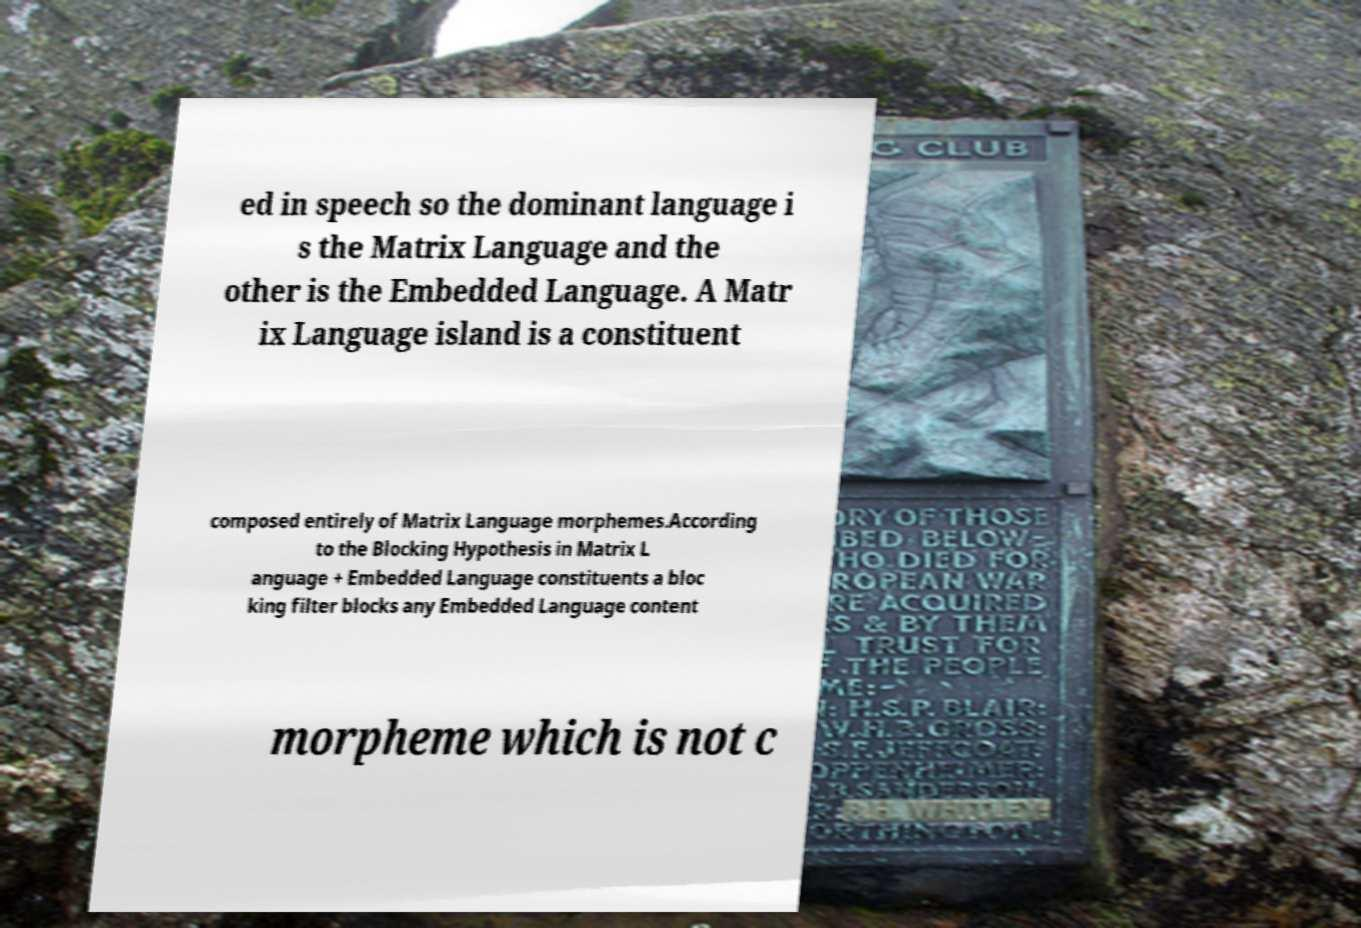For documentation purposes, I need the text within this image transcribed. Could you provide that? ed in speech so the dominant language i s the Matrix Language and the other is the Embedded Language. A Matr ix Language island is a constituent composed entirely of Matrix Language morphemes.According to the Blocking Hypothesis in Matrix L anguage + Embedded Language constituents a bloc king filter blocks any Embedded Language content morpheme which is not c 